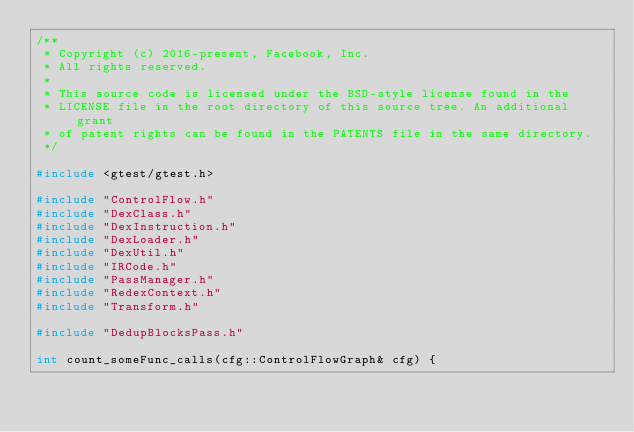Convert code to text. <code><loc_0><loc_0><loc_500><loc_500><_C++_>/**
 * Copyright (c) 2016-present, Facebook, Inc.
 * All rights reserved.
 *
 * This source code is licensed under the BSD-style license found in the
 * LICENSE file in the root directory of this source tree. An additional grant
 * of patent rights can be found in the PATENTS file in the same directory.
 */

#include <gtest/gtest.h>

#include "ControlFlow.h"
#include "DexClass.h"
#include "DexInstruction.h"
#include "DexLoader.h"
#include "DexUtil.h"
#include "IRCode.h"
#include "PassManager.h"
#include "RedexContext.h"
#include "Transform.h"

#include "DedupBlocksPass.h"

int count_someFunc_calls(cfg::ControlFlowGraph& cfg) {</code> 